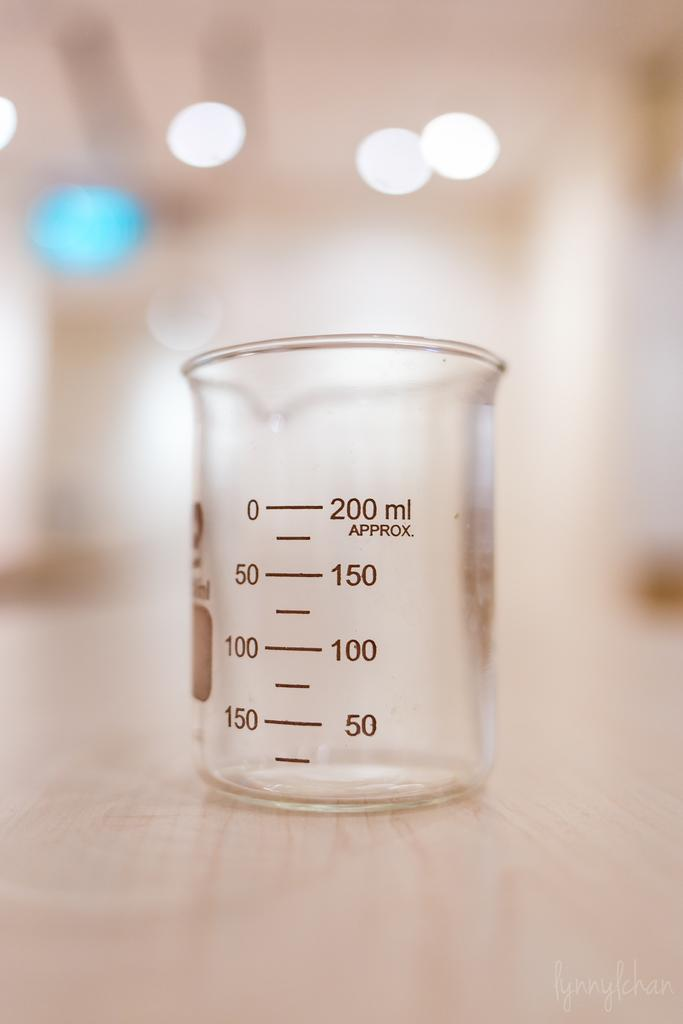<image>
Provide a brief description of the given image. A wide mouth 200 milliter flask with 50 milliliter graduations for measurment. 